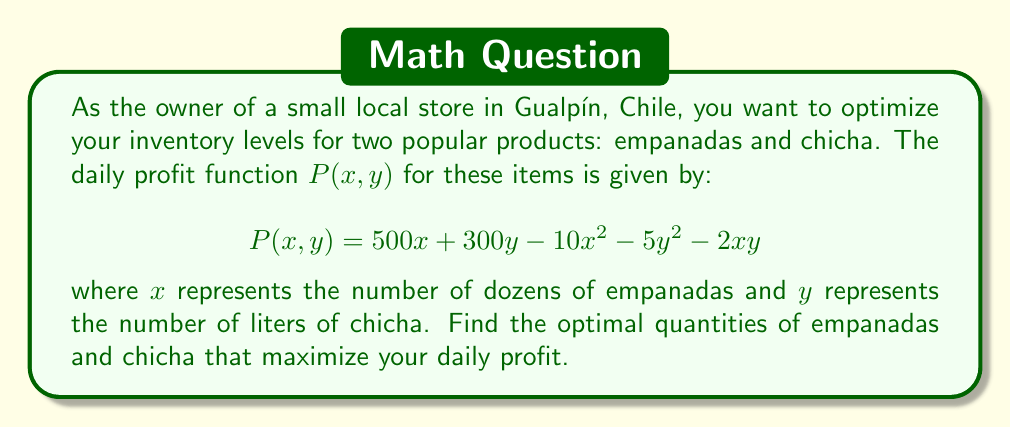Provide a solution to this math problem. To find the optimal quantities that maximize profit, we need to find the critical points of the profit function $P(x,y)$. We'll use partial derivatives and set them equal to zero.

Step 1: Calculate partial derivatives
$$\frac{\partial P}{\partial x} = 500 - 20x - 2y$$
$$\frac{\partial P}{\partial y} = 300 - 10y - 2x$$

Step 2: Set partial derivatives to zero and solve the system of equations
$$\frac{\partial P}{\partial x} = 0: 500 - 20x - 2y = 0$$
$$\frac{\partial P}{\partial y} = 0: 300 - 10y - 2x = 0$$

Step 3: Solve the system of equations
From the second equation:
$$x = 150 - 5y$$

Substitute into the first equation:
$$500 - 20(150 - 5y) - 2y = 0$$
$$500 - 3000 + 100y - 2y = 0$$
$$98y = 2500$$
$$y = \frac{2500}{98} \approx 25.51$$

Substitute back to find x:
$$x = 150 - 5(25.51) \approx 22.45$$

Step 4: Verify that this is a maximum using the second derivative test
$$\frac{\partial^2 P}{\partial x^2} = -20$$
$$\frac{\partial^2 P}{\partial y^2} = -10$$
$$\frac{\partial^2 P}{\partial x \partial y} = -2$$

The Hessian matrix is:
$$H = \begin{bmatrix} -20 & -2 \\ -2 & -10 \end{bmatrix}$$

The determinant of H is positive, and $\frac{\partial^2 P}{\partial x^2}$ is negative, confirming this is a maximum.

Step 5: Round to nearest whole number for practical inventory levels
$x \approx 22$ dozens of empanadas
$y \approx 26$ liters of chicha
Answer: 22 dozens of empanadas, 26 liters of chicha 